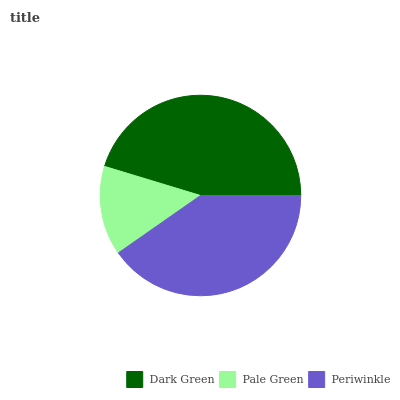Is Pale Green the minimum?
Answer yes or no. Yes. Is Dark Green the maximum?
Answer yes or no. Yes. Is Periwinkle the minimum?
Answer yes or no. No. Is Periwinkle the maximum?
Answer yes or no. No. Is Periwinkle greater than Pale Green?
Answer yes or no. Yes. Is Pale Green less than Periwinkle?
Answer yes or no. Yes. Is Pale Green greater than Periwinkle?
Answer yes or no. No. Is Periwinkle less than Pale Green?
Answer yes or no. No. Is Periwinkle the high median?
Answer yes or no. Yes. Is Periwinkle the low median?
Answer yes or no. Yes. Is Dark Green the high median?
Answer yes or no. No. Is Dark Green the low median?
Answer yes or no. No. 